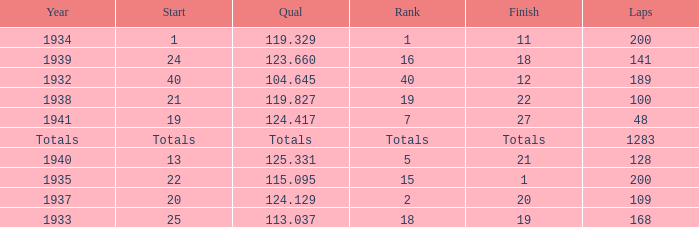What was the finish place with a qual of 123.660? 18.0. 